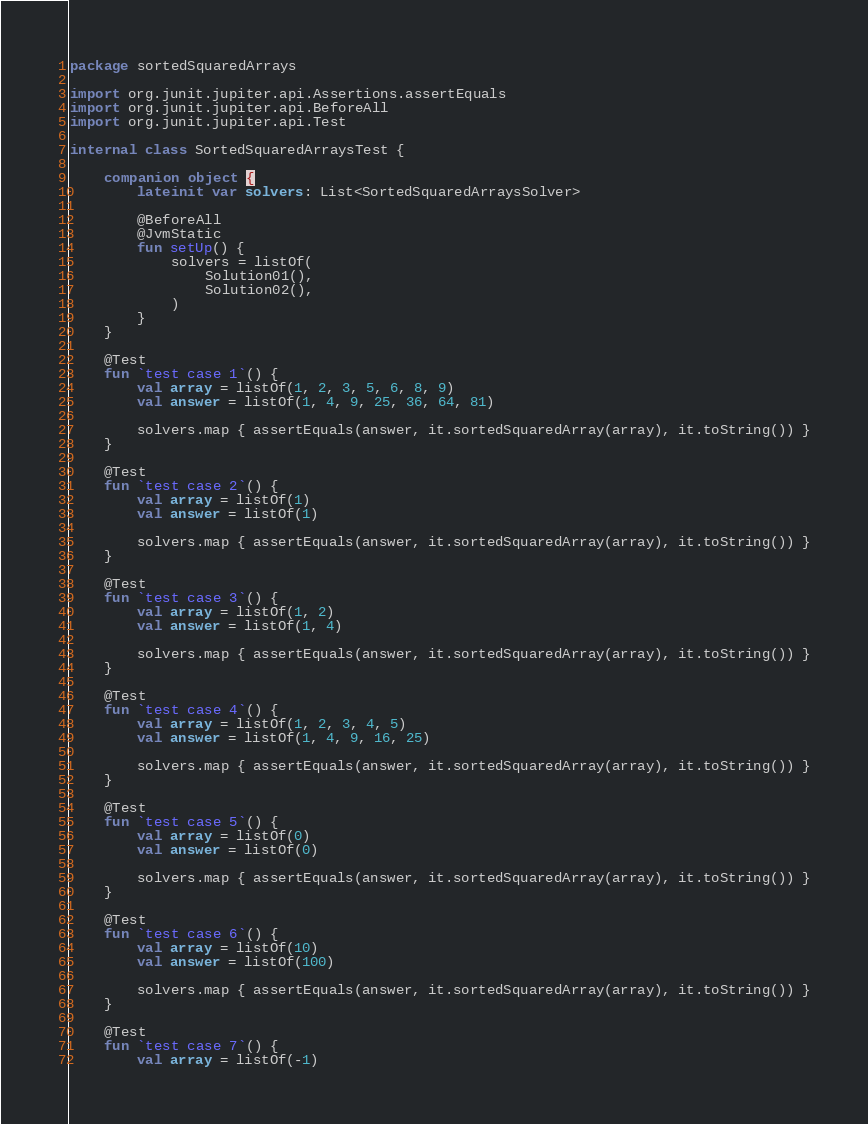<code> <loc_0><loc_0><loc_500><loc_500><_Kotlin_>package sortedSquaredArrays

import org.junit.jupiter.api.Assertions.assertEquals
import org.junit.jupiter.api.BeforeAll
import org.junit.jupiter.api.Test

internal class SortedSquaredArraysTest {

    companion object {
        lateinit var solvers: List<SortedSquaredArraysSolver>

        @BeforeAll
        @JvmStatic
        fun setUp() {
            solvers = listOf(
                Solution01(),
                Solution02(),
            )
        }
    }

    @Test
    fun `test case 1`() {
        val array = listOf(1, 2, 3, 5, 6, 8, 9)
        val answer = listOf(1, 4, 9, 25, 36, 64, 81)

        solvers.map { assertEquals(answer, it.sortedSquaredArray(array), it.toString()) }
    }

    @Test
    fun `test case 2`() {
        val array = listOf(1)
        val answer = listOf(1)

        solvers.map { assertEquals(answer, it.sortedSquaredArray(array), it.toString()) }
    }

    @Test
    fun `test case 3`() {
        val array = listOf(1, 2)
        val answer = listOf(1, 4)

        solvers.map { assertEquals(answer, it.sortedSquaredArray(array), it.toString()) }
    }

    @Test
    fun `test case 4`() {
        val array = listOf(1, 2, 3, 4, 5)
        val answer = listOf(1, 4, 9, 16, 25)

        solvers.map { assertEquals(answer, it.sortedSquaredArray(array), it.toString()) }
    }

    @Test
    fun `test case 5`() {
        val array = listOf(0)
        val answer = listOf(0)

        solvers.map { assertEquals(answer, it.sortedSquaredArray(array), it.toString()) }
    }

    @Test
    fun `test case 6`() {
        val array = listOf(10)
        val answer = listOf(100)

        solvers.map { assertEquals(answer, it.sortedSquaredArray(array), it.toString()) }
    }

    @Test
    fun `test case 7`() {
        val array = listOf(-1)</code> 